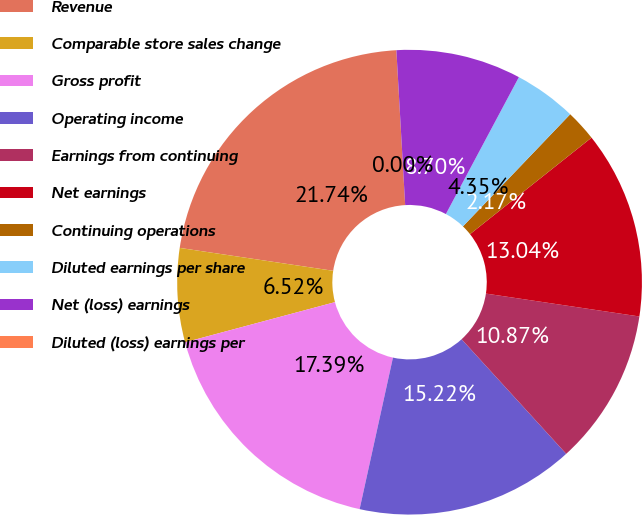<chart> <loc_0><loc_0><loc_500><loc_500><pie_chart><fcel>Revenue<fcel>Comparable store sales change<fcel>Gross profit<fcel>Operating income<fcel>Earnings from continuing<fcel>Net earnings<fcel>Continuing operations<fcel>Diluted earnings per share<fcel>Net (loss) earnings<fcel>Diluted (loss) earnings per<nl><fcel>21.74%<fcel>6.52%<fcel>17.39%<fcel>15.22%<fcel>10.87%<fcel>13.04%<fcel>2.17%<fcel>4.35%<fcel>8.7%<fcel>0.0%<nl></chart> 